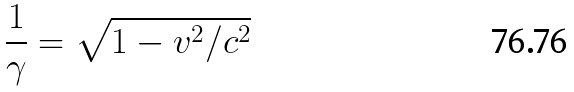<formula> <loc_0><loc_0><loc_500><loc_500>\frac { 1 } { \gamma } = \sqrt { 1 - v ^ { 2 } / c ^ { 2 } }</formula> 